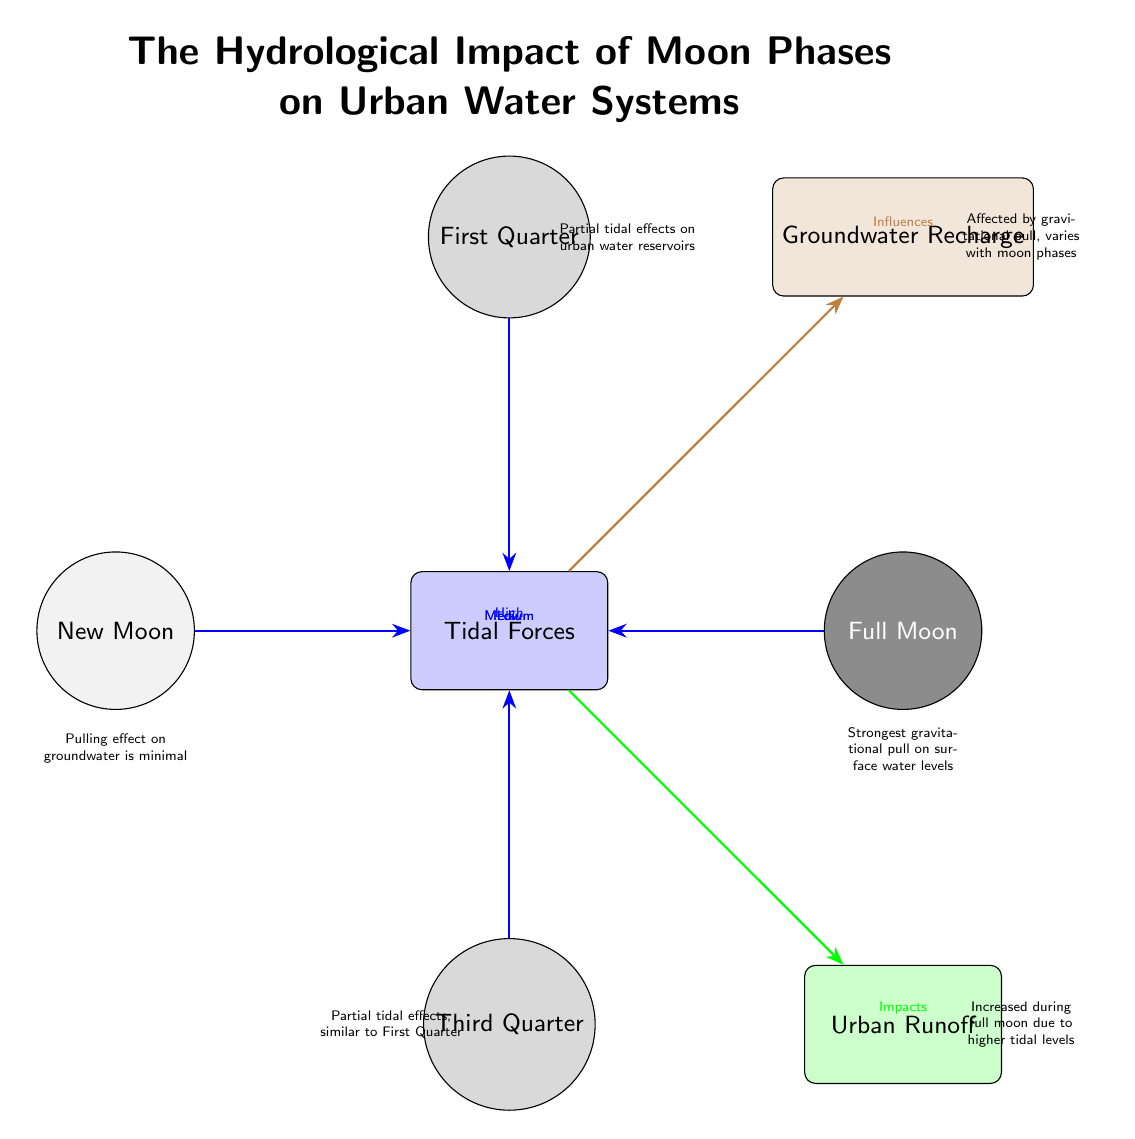What are the four moon phases depicted in the diagram? The diagram displays four nodes representing different phases of the moon: New Moon, First Quarter, Full Moon, and Third Quarter.
Answer: New Moon, First Quarter, Full Moon, Third Quarter Which moon phase has the highest tidal force? The Full Moon node is colored gray and is positioned to indicate it has the highest tidal force. This is confirmed by the label "High" connected to the Tidal Forces node.
Answer: Full Moon How many effects are represented in the diagram? The diagram includes three effect nodes: Tidal Forces, Urban Runoff, and Groundwater Recharge, which denote the various impacts observed in urban water systems.
Answer: 3 What effect is influenced the most by Full Moon tide? The Urban Runoff node is impacted significantly during the Full Moon, denoted by the connection from the Tidal Forces with the label "Impacts."
Answer: Urban Runoff How does the tidal force affect groundwater during New Moon? The New Moon phase has minimal influence on groundwater, as indicated by the description attached to the New Moon node stating "Pulling effect on groundwater is minimal."
Answer: Minimal How does tidal force during First Quarter compare with Third Quarter? Both the First Quarter and Third Quarter nodes point to medium tidal effects on urban water reservoirs, indicated by the same label "Medium" under both connections to Tidal Forces.
Answer: Medium What does the gray shading of the Full Moon signify? The dark gray shading of the Full Moon node signifies that it produces the strongest gravitational pull on surface water levels, as indicated by the description linked to this node.
Answer: Strongest gravitational pull What type of connection exists between Tidal Forces and Groundwater Recharge? The connection is represented through a brown arrow leading from Tidal Forces to Groundwater Recharge, which is labeled "Influences," indicating a specific influence rather than direct impact.
Answer: Influences 